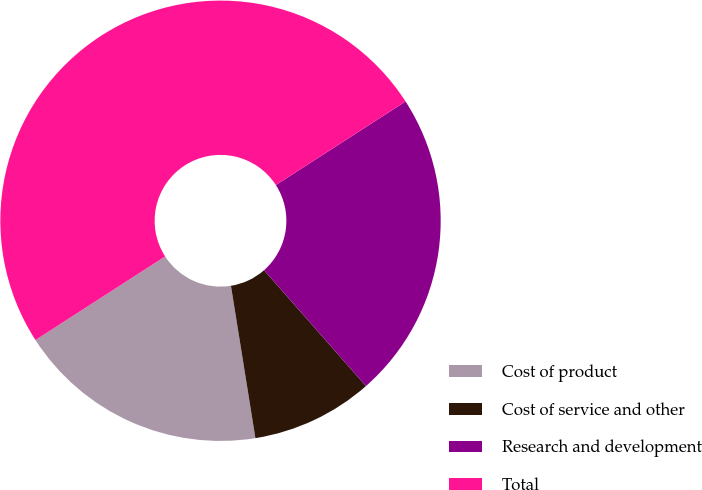Convert chart. <chart><loc_0><loc_0><loc_500><loc_500><pie_chart><fcel>Cost of product<fcel>Cost of service and other<fcel>Research and development<fcel>Total<nl><fcel>18.42%<fcel>8.95%<fcel>22.63%<fcel>50.0%<nl></chart> 